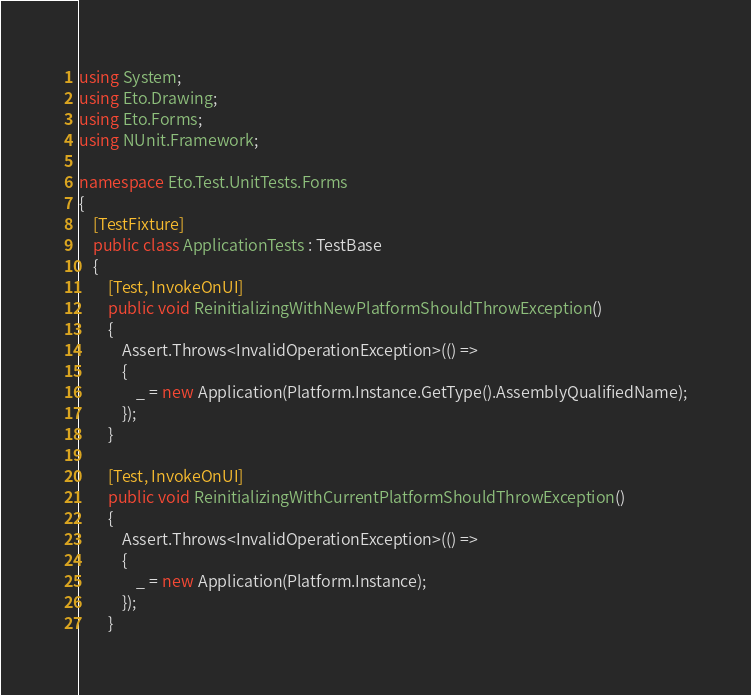<code> <loc_0><loc_0><loc_500><loc_500><_C#_>using System;
using Eto.Drawing;
using Eto.Forms;
using NUnit.Framework;

namespace Eto.Test.UnitTests.Forms
{
	[TestFixture]
	public class ApplicationTests : TestBase
	{
		[Test, InvokeOnUI]
		public void ReinitializingWithNewPlatformShouldThrowException()
		{
			Assert.Throws<InvalidOperationException>(() =>
			{
				_ = new Application(Platform.Instance.GetType().AssemblyQualifiedName);
			});
		}

		[Test, InvokeOnUI]
		public void ReinitializingWithCurrentPlatformShouldThrowException()
		{
			Assert.Throws<InvalidOperationException>(() =>
			{
				_ = new Application(Platform.Instance);
			});
		}
</code> 